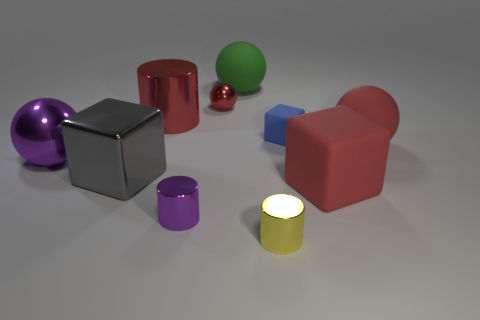Can you tell me about the different shapes and their colors in this image? Certainly! The image shows a variety of geometric shapes with different colors. There's a purple sphere, a grey cube, a red cylinder, a green sphere, a blue cuboid, and a small red sphere. Additionally, there is a pink cylinder and a yellow cylinder with what seems to be a glowing top surface, possibly indicating it is lit from within.  Does the image seem to have any sort of pattern or theme with the placement of the objects? The objects are arranged without a clear pattern; they seem randomly placed. However, there is a theme of contrasting sizes and vivid colors, which creates a visually interesting composition. Also, the shadows and lighting suggest that the objects exist within a three-dimensional space, giving the scene natural depth. 